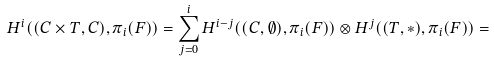<formula> <loc_0><loc_0><loc_500><loc_500>H ^ { i } ( ( C \times T , C ) , \pi _ { i } ( F ) ) = \sum _ { j = 0 } ^ { i } H ^ { i - j } ( ( C , \emptyset ) , \pi _ { i } ( F ) ) \otimes H ^ { j } ( ( T , * ) , \pi _ { i } ( F ) ) =</formula> 